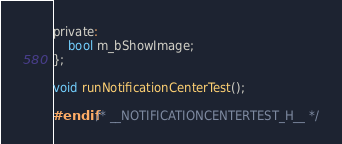Convert code to text. <code><loc_0><loc_0><loc_500><loc_500><_C_>private:
    bool m_bShowImage;
};

void runNotificationCenterTest();

#endif /* __NOTIFICATIONCENTERTEST_H__ */
</code> 